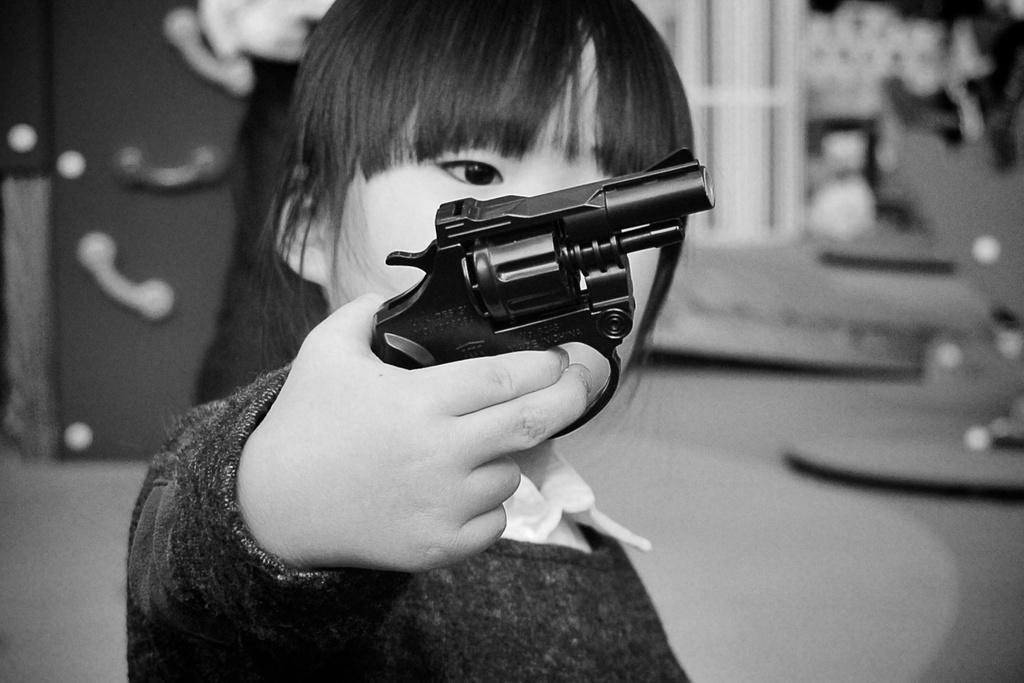What is the color scheme of the image? The image is black and white. What is the main subject of the image? There is a kid in the image. What is the kid doing in the image? The kid is standing. What is the kid holding in the image? The kid is holding a handgun. How would you describe the background of the image? The background appears slightly blurred. What type of creature is present in the image? There is no creature present in the image; it features a kid holding a handgun. What fact can be learned about the committee from the image? There is no information about a committee in the image. 